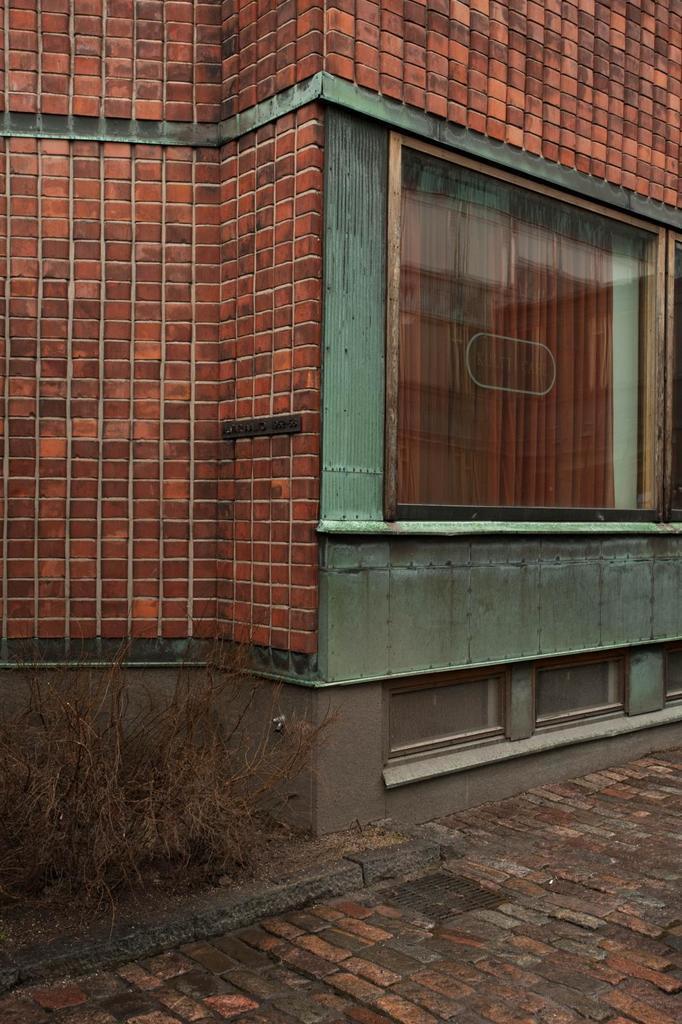Can you describe this image briefly? There is a building which is brick in color and there is a glass window in the right corner. 